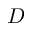Convert formula to latex. <formula><loc_0><loc_0><loc_500><loc_500>D</formula> 